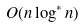<formula> <loc_0><loc_0><loc_500><loc_500>O ( n \log ^ { * } n )</formula> 